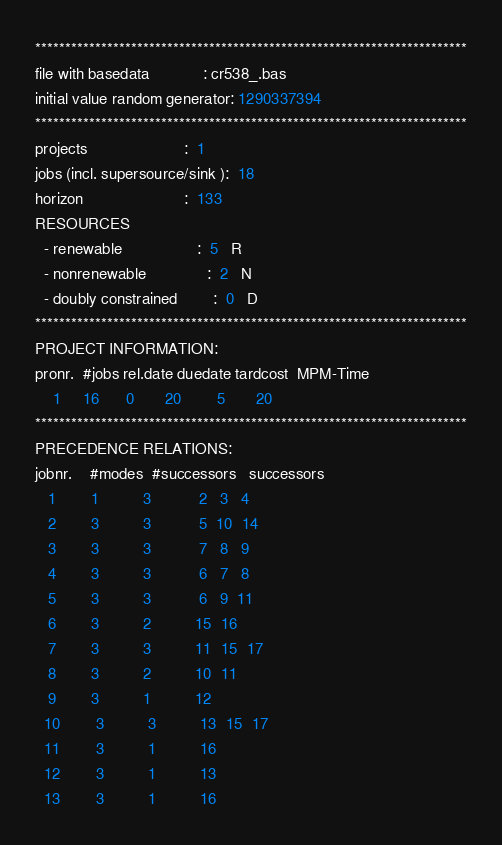Convert code to text. <code><loc_0><loc_0><loc_500><loc_500><_ObjectiveC_>************************************************************************
file with basedata            : cr538_.bas
initial value random generator: 1290337394
************************************************************************
projects                      :  1
jobs (incl. supersource/sink ):  18
horizon                       :  133
RESOURCES
  - renewable                 :  5   R
  - nonrenewable              :  2   N
  - doubly constrained        :  0   D
************************************************************************
PROJECT INFORMATION:
pronr.  #jobs rel.date duedate tardcost  MPM-Time
    1     16      0       20        5       20
************************************************************************
PRECEDENCE RELATIONS:
jobnr.    #modes  #successors   successors
   1        1          3           2   3   4
   2        3          3           5  10  14
   3        3          3           7   8   9
   4        3          3           6   7   8
   5        3          3           6   9  11
   6        3          2          15  16
   7        3          3          11  15  17
   8        3          2          10  11
   9        3          1          12
  10        3          3          13  15  17
  11        3          1          16
  12        3          1          13
  13        3          1          16</code> 